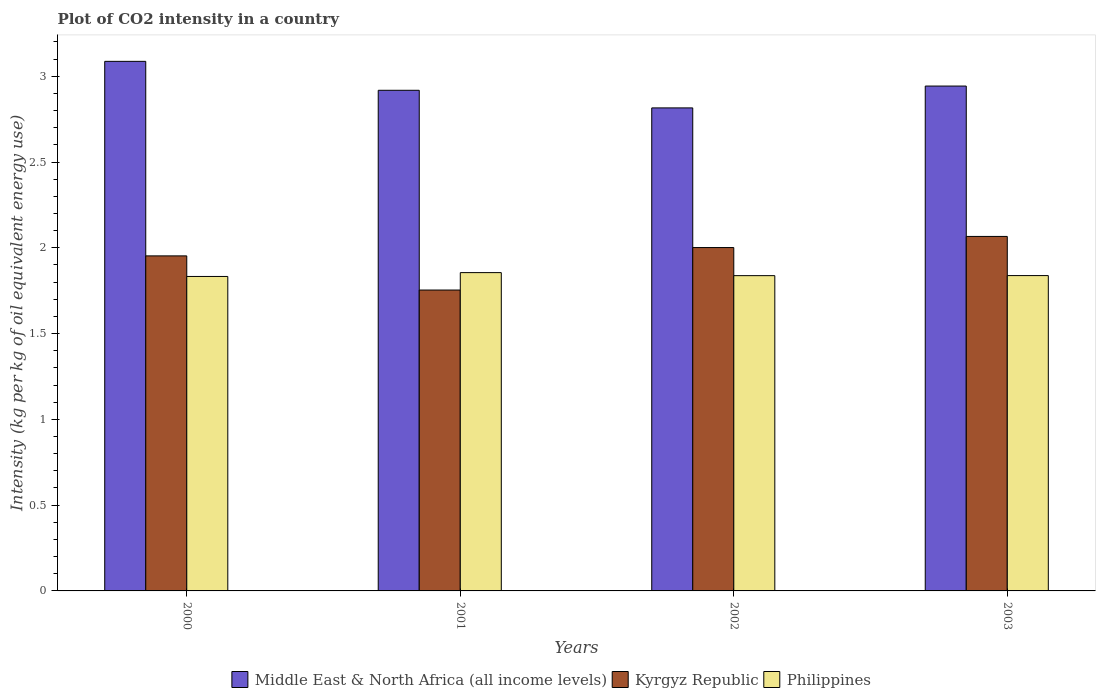Are the number of bars per tick equal to the number of legend labels?
Keep it short and to the point. Yes. Are the number of bars on each tick of the X-axis equal?
Provide a short and direct response. Yes. How many bars are there on the 2nd tick from the left?
Keep it short and to the point. 3. What is the CO2 intensity in in Middle East & North Africa (all income levels) in 2003?
Offer a very short reply. 2.94. Across all years, what is the maximum CO2 intensity in in Kyrgyz Republic?
Your answer should be very brief. 2.07. Across all years, what is the minimum CO2 intensity in in Middle East & North Africa (all income levels)?
Provide a succinct answer. 2.82. In which year was the CO2 intensity in in Kyrgyz Republic maximum?
Offer a terse response. 2003. What is the total CO2 intensity in in Kyrgyz Republic in the graph?
Keep it short and to the point. 7.78. What is the difference between the CO2 intensity in in Philippines in 2001 and that in 2002?
Keep it short and to the point. 0.02. What is the difference between the CO2 intensity in in Middle East & North Africa (all income levels) in 2001 and the CO2 intensity in in Kyrgyz Republic in 2002?
Your response must be concise. 0.92. What is the average CO2 intensity in in Philippines per year?
Ensure brevity in your answer.  1.84. In the year 2000, what is the difference between the CO2 intensity in in Philippines and CO2 intensity in in Kyrgyz Republic?
Provide a succinct answer. -0.12. In how many years, is the CO2 intensity in in Middle East & North Africa (all income levels) greater than 0.4 kg?
Your response must be concise. 4. What is the ratio of the CO2 intensity in in Kyrgyz Republic in 2001 to that in 2002?
Your answer should be compact. 0.88. Is the CO2 intensity in in Philippines in 2001 less than that in 2002?
Your answer should be very brief. No. What is the difference between the highest and the second highest CO2 intensity in in Philippines?
Provide a succinct answer. 0.02. What is the difference between the highest and the lowest CO2 intensity in in Kyrgyz Republic?
Provide a succinct answer. 0.31. In how many years, is the CO2 intensity in in Philippines greater than the average CO2 intensity in in Philippines taken over all years?
Your response must be concise. 1. What does the 3rd bar from the left in 2002 represents?
Provide a succinct answer. Philippines. What does the 2nd bar from the right in 2000 represents?
Provide a succinct answer. Kyrgyz Republic. Are all the bars in the graph horizontal?
Your answer should be compact. No. How many years are there in the graph?
Offer a very short reply. 4. Does the graph contain grids?
Your answer should be very brief. No. How many legend labels are there?
Make the answer very short. 3. How are the legend labels stacked?
Provide a short and direct response. Horizontal. What is the title of the graph?
Offer a terse response. Plot of CO2 intensity in a country. Does "Portugal" appear as one of the legend labels in the graph?
Provide a short and direct response. No. What is the label or title of the X-axis?
Offer a terse response. Years. What is the label or title of the Y-axis?
Keep it short and to the point. Intensity (kg per kg of oil equivalent energy use). What is the Intensity (kg per kg of oil equivalent energy use) of Middle East & North Africa (all income levels) in 2000?
Ensure brevity in your answer.  3.09. What is the Intensity (kg per kg of oil equivalent energy use) in Kyrgyz Republic in 2000?
Provide a short and direct response. 1.95. What is the Intensity (kg per kg of oil equivalent energy use) of Philippines in 2000?
Your response must be concise. 1.83. What is the Intensity (kg per kg of oil equivalent energy use) of Middle East & North Africa (all income levels) in 2001?
Provide a short and direct response. 2.92. What is the Intensity (kg per kg of oil equivalent energy use) of Kyrgyz Republic in 2001?
Give a very brief answer. 1.75. What is the Intensity (kg per kg of oil equivalent energy use) in Philippines in 2001?
Offer a terse response. 1.86. What is the Intensity (kg per kg of oil equivalent energy use) of Middle East & North Africa (all income levels) in 2002?
Your answer should be very brief. 2.82. What is the Intensity (kg per kg of oil equivalent energy use) of Kyrgyz Republic in 2002?
Offer a very short reply. 2. What is the Intensity (kg per kg of oil equivalent energy use) of Philippines in 2002?
Provide a short and direct response. 1.84. What is the Intensity (kg per kg of oil equivalent energy use) of Middle East & North Africa (all income levels) in 2003?
Offer a terse response. 2.94. What is the Intensity (kg per kg of oil equivalent energy use) of Kyrgyz Republic in 2003?
Your response must be concise. 2.07. What is the Intensity (kg per kg of oil equivalent energy use) in Philippines in 2003?
Your response must be concise. 1.84. Across all years, what is the maximum Intensity (kg per kg of oil equivalent energy use) of Middle East & North Africa (all income levels)?
Your answer should be very brief. 3.09. Across all years, what is the maximum Intensity (kg per kg of oil equivalent energy use) in Kyrgyz Republic?
Provide a short and direct response. 2.07. Across all years, what is the maximum Intensity (kg per kg of oil equivalent energy use) in Philippines?
Ensure brevity in your answer.  1.86. Across all years, what is the minimum Intensity (kg per kg of oil equivalent energy use) of Middle East & North Africa (all income levels)?
Provide a succinct answer. 2.82. Across all years, what is the minimum Intensity (kg per kg of oil equivalent energy use) of Kyrgyz Republic?
Give a very brief answer. 1.75. Across all years, what is the minimum Intensity (kg per kg of oil equivalent energy use) in Philippines?
Provide a succinct answer. 1.83. What is the total Intensity (kg per kg of oil equivalent energy use) in Middle East & North Africa (all income levels) in the graph?
Offer a terse response. 11.76. What is the total Intensity (kg per kg of oil equivalent energy use) of Kyrgyz Republic in the graph?
Provide a succinct answer. 7.78. What is the total Intensity (kg per kg of oil equivalent energy use) of Philippines in the graph?
Offer a terse response. 7.36. What is the difference between the Intensity (kg per kg of oil equivalent energy use) of Middle East & North Africa (all income levels) in 2000 and that in 2001?
Your answer should be compact. 0.17. What is the difference between the Intensity (kg per kg of oil equivalent energy use) of Kyrgyz Republic in 2000 and that in 2001?
Offer a terse response. 0.2. What is the difference between the Intensity (kg per kg of oil equivalent energy use) in Philippines in 2000 and that in 2001?
Offer a terse response. -0.02. What is the difference between the Intensity (kg per kg of oil equivalent energy use) in Middle East & North Africa (all income levels) in 2000 and that in 2002?
Your response must be concise. 0.27. What is the difference between the Intensity (kg per kg of oil equivalent energy use) of Kyrgyz Republic in 2000 and that in 2002?
Your answer should be very brief. -0.05. What is the difference between the Intensity (kg per kg of oil equivalent energy use) of Philippines in 2000 and that in 2002?
Offer a very short reply. -0. What is the difference between the Intensity (kg per kg of oil equivalent energy use) of Middle East & North Africa (all income levels) in 2000 and that in 2003?
Your response must be concise. 0.14. What is the difference between the Intensity (kg per kg of oil equivalent energy use) in Kyrgyz Republic in 2000 and that in 2003?
Your answer should be very brief. -0.11. What is the difference between the Intensity (kg per kg of oil equivalent energy use) in Philippines in 2000 and that in 2003?
Make the answer very short. -0.01. What is the difference between the Intensity (kg per kg of oil equivalent energy use) of Middle East & North Africa (all income levels) in 2001 and that in 2002?
Make the answer very short. 0.1. What is the difference between the Intensity (kg per kg of oil equivalent energy use) in Kyrgyz Republic in 2001 and that in 2002?
Your response must be concise. -0.25. What is the difference between the Intensity (kg per kg of oil equivalent energy use) of Philippines in 2001 and that in 2002?
Provide a succinct answer. 0.02. What is the difference between the Intensity (kg per kg of oil equivalent energy use) of Middle East & North Africa (all income levels) in 2001 and that in 2003?
Make the answer very short. -0.02. What is the difference between the Intensity (kg per kg of oil equivalent energy use) in Kyrgyz Republic in 2001 and that in 2003?
Give a very brief answer. -0.31. What is the difference between the Intensity (kg per kg of oil equivalent energy use) in Philippines in 2001 and that in 2003?
Your answer should be very brief. 0.02. What is the difference between the Intensity (kg per kg of oil equivalent energy use) of Middle East & North Africa (all income levels) in 2002 and that in 2003?
Provide a short and direct response. -0.13. What is the difference between the Intensity (kg per kg of oil equivalent energy use) of Kyrgyz Republic in 2002 and that in 2003?
Offer a very short reply. -0.06. What is the difference between the Intensity (kg per kg of oil equivalent energy use) in Philippines in 2002 and that in 2003?
Make the answer very short. -0. What is the difference between the Intensity (kg per kg of oil equivalent energy use) of Middle East & North Africa (all income levels) in 2000 and the Intensity (kg per kg of oil equivalent energy use) of Kyrgyz Republic in 2001?
Your answer should be very brief. 1.33. What is the difference between the Intensity (kg per kg of oil equivalent energy use) of Middle East & North Africa (all income levels) in 2000 and the Intensity (kg per kg of oil equivalent energy use) of Philippines in 2001?
Provide a succinct answer. 1.23. What is the difference between the Intensity (kg per kg of oil equivalent energy use) of Kyrgyz Republic in 2000 and the Intensity (kg per kg of oil equivalent energy use) of Philippines in 2001?
Ensure brevity in your answer.  0.1. What is the difference between the Intensity (kg per kg of oil equivalent energy use) in Middle East & North Africa (all income levels) in 2000 and the Intensity (kg per kg of oil equivalent energy use) in Kyrgyz Republic in 2002?
Ensure brevity in your answer.  1.09. What is the difference between the Intensity (kg per kg of oil equivalent energy use) in Middle East & North Africa (all income levels) in 2000 and the Intensity (kg per kg of oil equivalent energy use) in Philippines in 2002?
Your answer should be compact. 1.25. What is the difference between the Intensity (kg per kg of oil equivalent energy use) of Kyrgyz Republic in 2000 and the Intensity (kg per kg of oil equivalent energy use) of Philippines in 2002?
Ensure brevity in your answer.  0.12. What is the difference between the Intensity (kg per kg of oil equivalent energy use) in Middle East & North Africa (all income levels) in 2000 and the Intensity (kg per kg of oil equivalent energy use) in Kyrgyz Republic in 2003?
Provide a succinct answer. 1.02. What is the difference between the Intensity (kg per kg of oil equivalent energy use) in Middle East & North Africa (all income levels) in 2000 and the Intensity (kg per kg of oil equivalent energy use) in Philippines in 2003?
Provide a short and direct response. 1.25. What is the difference between the Intensity (kg per kg of oil equivalent energy use) of Kyrgyz Republic in 2000 and the Intensity (kg per kg of oil equivalent energy use) of Philippines in 2003?
Keep it short and to the point. 0.11. What is the difference between the Intensity (kg per kg of oil equivalent energy use) of Middle East & North Africa (all income levels) in 2001 and the Intensity (kg per kg of oil equivalent energy use) of Kyrgyz Republic in 2002?
Keep it short and to the point. 0.92. What is the difference between the Intensity (kg per kg of oil equivalent energy use) in Middle East & North Africa (all income levels) in 2001 and the Intensity (kg per kg of oil equivalent energy use) in Philippines in 2002?
Give a very brief answer. 1.08. What is the difference between the Intensity (kg per kg of oil equivalent energy use) in Kyrgyz Republic in 2001 and the Intensity (kg per kg of oil equivalent energy use) in Philippines in 2002?
Provide a succinct answer. -0.08. What is the difference between the Intensity (kg per kg of oil equivalent energy use) of Middle East & North Africa (all income levels) in 2001 and the Intensity (kg per kg of oil equivalent energy use) of Kyrgyz Republic in 2003?
Keep it short and to the point. 0.85. What is the difference between the Intensity (kg per kg of oil equivalent energy use) in Middle East & North Africa (all income levels) in 2001 and the Intensity (kg per kg of oil equivalent energy use) in Philippines in 2003?
Provide a short and direct response. 1.08. What is the difference between the Intensity (kg per kg of oil equivalent energy use) in Kyrgyz Republic in 2001 and the Intensity (kg per kg of oil equivalent energy use) in Philippines in 2003?
Your response must be concise. -0.08. What is the difference between the Intensity (kg per kg of oil equivalent energy use) in Middle East & North Africa (all income levels) in 2002 and the Intensity (kg per kg of oil equivalent energy use) in Kyrgyz Republic in 2003?
Provide a short and direct response. 0.75. What is the difference between the Intensity (kg per kg of oil equivalent energy use) of Middle East & North Africa (all income levels) in 2002 and the Intensity (kg per kg of oil equivalent energy use) of Philippines in 2003?
Offer a very short reply. 0.98. What is the difference between the Intensity (kg per kg of oil equivalent energy use) of Kyrgyz Republic in 2002 and the Intensity (kg per kg of oil equivalent energy use) of Philippines in 2003?
Make the answer very short. 0.16. What is the average Intensity (kg per kg of oil equivalent energy use) of Middle East & North Africa (all income levels) per year?
Ensure brevity in your answer.  2.94. What is the average Intensity (kg per kg of oil equivalent energy use) of Kyrgyz Republic per year?
Your response must be concise. 1.94. What is the average Intensity (kg per kg of oil equivalent energy use) in Philippines per year?
Offer a very short reply. 1.84. In the year 2000, what is the difference between the Intensity (kg per kg of oil equivalent energy use) of Middle East & North Africa (all income levels) and Intensity (kg per kg of oil equivalent energy use) of Kyrgyz Republic?
Offer a terse response. 1.13. In the year 2000, what is the difference between the Intensity (kg per kg of oil equivalent energy use) in Middle East & North Africa (all income levels) and Intensity (kg per kg of oil equivalent energy use) in Philippines?
Offer a very short reply. 1.25. In the year 2000, what is the difference between the Intensity (kg per kg of oil equivalent energy use) of Kyrgyz Republic and Intensity (kg per kg of oil equivalent energy use) of Philippines?
Ensure brevity in your answer.  0.12. In the year 2001, what is the difference between the Intensity (kg per kg of oil equivalent energy use) of Middle East & North Africa (all income levels) and Intensity (kg per kg of oil equivalent energy use) of Kyrgyz Republic?
Your response must be concise. 1.16. In the year 2001, what is the difference between the Intensity (kg per kg of oil equivalent energy use) of Middle East & North Africa (all income levels) and Intensity (kg per kg of oil equivalent energy use) of Philippines?
Your answer should be compact. 1.06. In the year 2001, what is the difference between the Intensity (kg per kg of oil equivalent energy use) of Kyrgyz Republic and Intensity (kg per kg of oil equivalent energy use) of Philippines?
Keep it short and to the point. -0.1. In the year 2002, what is the difference between the Intensity (kg per kg of oil equivalent energy use) in Middle East & North Africa (all income levels) and Intensity (kg per kg of oil equivalent energy use) in Kyrgyz Republic?
Keep it short and to the point. 0.81. In the year 2002, what is the difference between the Intensity (kg per kg of oil equivalent energy use) of Middle East & North Africa (all income levels) and Intensity (kg per kg of oil equivalent energy use) of Philippines?
Offer a terse response. 0.98. In the year 2002, what is the difference between the Intensity (kg per kg of oil equivalent energy use) in Kyrgyz Republic and Intensity (kg per kg of oil equivalent energy use) in Philippines?
Provide a short and direct response. 0.16. In the year 2003, what is the difference between the Intensity (kg per kg of oil equivalent energy use) of Middle East & North Africa (all income levels) and Intensity (kg per kg of oil equivalent energy use) of Kyrgyz Republic?
Give a very brief answer. 0.88. In the year 2003, what is the difference between the Intensity (kg per kg of oil equivalent energy use) in Middle East & North Africa (all income levels) and Intensity (kg per kg of oil equivalent energy use) in Philippines?
Make the answer very short. 1.1. In the year 2003, what is the difference between the Intensity (kg per kg of oil equivalent energy use) in Kyrgyz Republic and Intensity (kg per kg of oil equivalent energy use) in Philippines?
Ensure brevity in your answer.  0.23. What is the ratio of the Intensity (kg per kg of oil equivalent energy use) in Middle East & North Africa (all income levels) in 2000 to that in 2001?
Keep it short and to the point. 1.06. What is the ratio of the Intensity (kg per kg of oil equivalent energy use) in Kyrgyz Republic in 2000 to that in 2001?
Give a very brief answer. 1.11. What is the ratio of the Intensity (kg per kg of oil equivalent energy use) in Philippines in 2000 to that in 2001?
Give a very brief answer. 0.99. What is the ratio of the Intensity (kg per kg of oil equivalent energy use) of Middle East & North Africa (all income levels) in 2000 to that in 2002?
Ensure brevity in your answer.  1.1. What is the ratio of the Intensity (kg per kg of oil equivalent energy use) of Kyrgyz Republic in 2000 to that in 2002?
Give a very brief answer. 0.98. What is the ratio of the Intensity (kg per kg of oil equivalent energy use) in Philippines in 2000 to that in 2002?
Offer a very short reply. 1. What is the ratio of the Intensity (kg per kg of oil equivalent energy use) of Middle East & North Africa (all income levels) in 2000 to that in 2003?
Your answer should be compact. 1.05. What is the ratio of the Intensity (kg per kg of oil equivalent energy use) in Kyrgyz Republic in 2000 to that in 2003?
Make the answer very short. 0.95. What is the ratio of the Intensity (kg per kg of oil equivalent energy use) of Middle East & North Africa (all income levels) in 2001 to that in 2002?
Give a very brief answer. 1.04. What is the ratio of the Intensity (kg per kg of oil equivalent energy use) of Kyrgyz Republic in 2001 to that in 2002?
Your answer should be compact. 0.88. What is the ratio of the Intensity (kg per kg of oil equivalent energy use) of Philippines in 2001 to that in 2002?
Offer a very short reply. 1.01. What is the ratio of the Intensity (kg per kg of oil equivalent energy use) in Middle East & North Africa (all income levels) in 2001 to that in 2003?
Your answer should be very brief. 0.99. What is the ratio of the Intensity (kg per kg of oil equivalent energy use) of Kyrgyz Republic in 2001 to that in 2003?
Your answer should be compact. 0.85. What is the ratio of the Intensity (kg per kg of oil equivalent energy use) of Philippines in 2001 to that in 2003?
Give a very brief answer. 1.01. What is the ratio of the Intensity (kg per kg of oil equivalent energy use) of Middle East & North Africa (all income levels) in 2002 to that in 2003?
Keep it short and to the point. 0.96. What is the ratio of the Intensity (kg per kg of oil equivalent energy use) in Kyrgyz Republic in 2002 to that in 2003?
Provide a succinct answer. 0.97. What is the ratio of the Intensity (kg per kg of oil equivalent energy use) of Philippines in 2002 to that in 2003?
Make the answer very short. 1. What is the difference between the highest and the second highest Intensity (kg per kg of oil equivalent energy use) in Middle East & North Africa (all income levels)?
Your response must be concise. 0.14. What is the difference between the highest and the second highest Intensity (kg per kg of oil equivalent energy use) in Kyrgyz Republic?
Your answer should be compact. 0.06. What is the difference between the highest and the second highest Intensity (kg per kg of oil equivalent energy use) of Philippines?
Offer a terse response. 0.02. What is the difference between the highest and the lowest Intensity (kg per kg of oil equivalent energy use) of Middle East & North Africa (all income levels)?
Your answer should be very brief. 0.27. What is the difference between the highest and the lowest Intensity (kg per kg of oil equivalent energy use) in Kyrgyz Republic?
Your answer should be compact. 0.31. What is the difference between the highest and the lowest Intensity (kg per kg of oil equivalent energy use) of Philippines?
Your response must be concise. 0.02. 